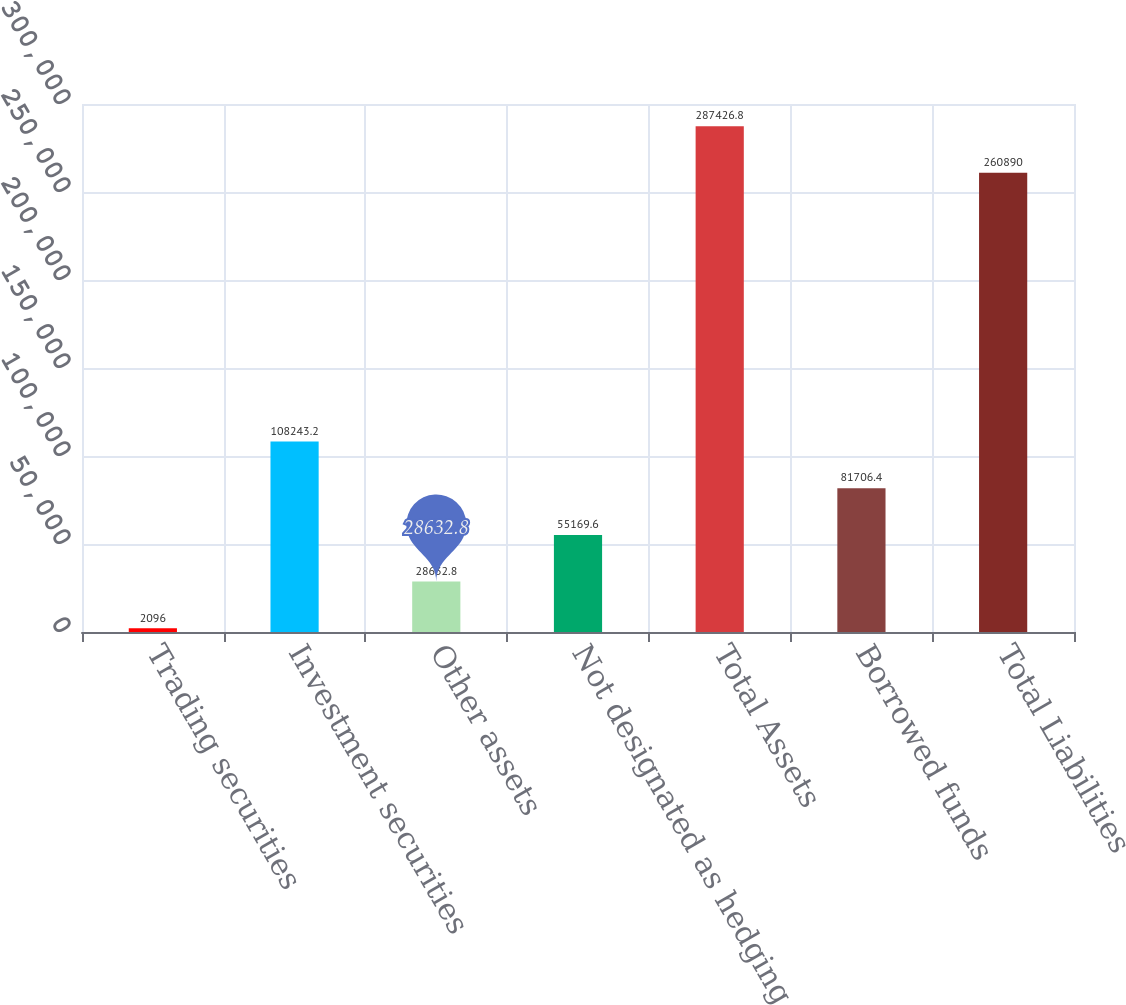Convert chart. <chart><loc_0><loc_0><loc_500><loc_500><bar_chart><fcel>Trading securities<fcel>Investment securities<fcel>Other assets<fcel>Not designated as hedging<fcel>Total Assets<fcel>Borrowed funds<fcel>Total Liabilities<nl><fcel>2096<fcel>108243<fcel>28632.8<fcel>55169.6<fcel>287427<fcel>81706.4<fcel>260890<nl></chart> 